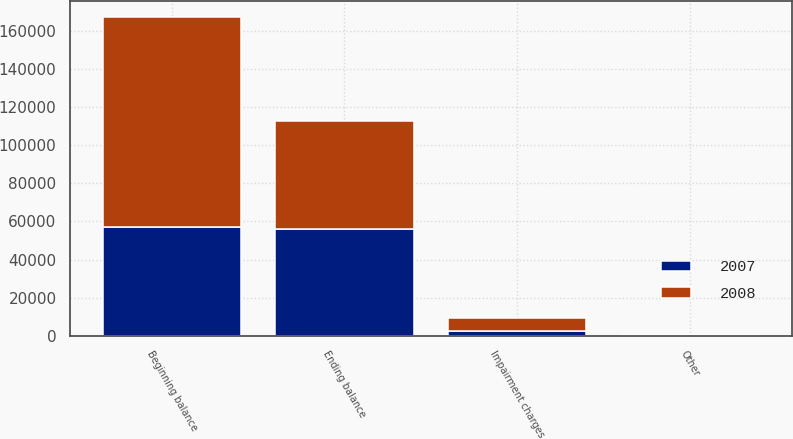Convert chart to OTSL. <chart><loc_0><loc_0><loc_500><loc_500><stacked_bar_chart><ecel><fcel>Beginning balance<fcel>Impairment charges<fcel>Other<fcel>Ending balance<nl><fcel>2007<fcel>56915<fcel>2498<fcel>184<fcel>55901<nl><fcel>2008<fcel>110764<fcel>7000<fcel>213<fcel>56915<nl></chart> 